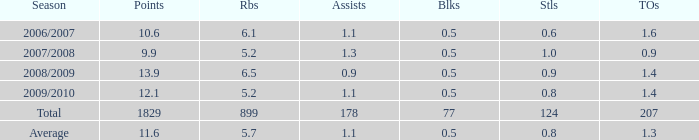How many blocks are there when the rebounds are fewer than 5.2? 0.0. 